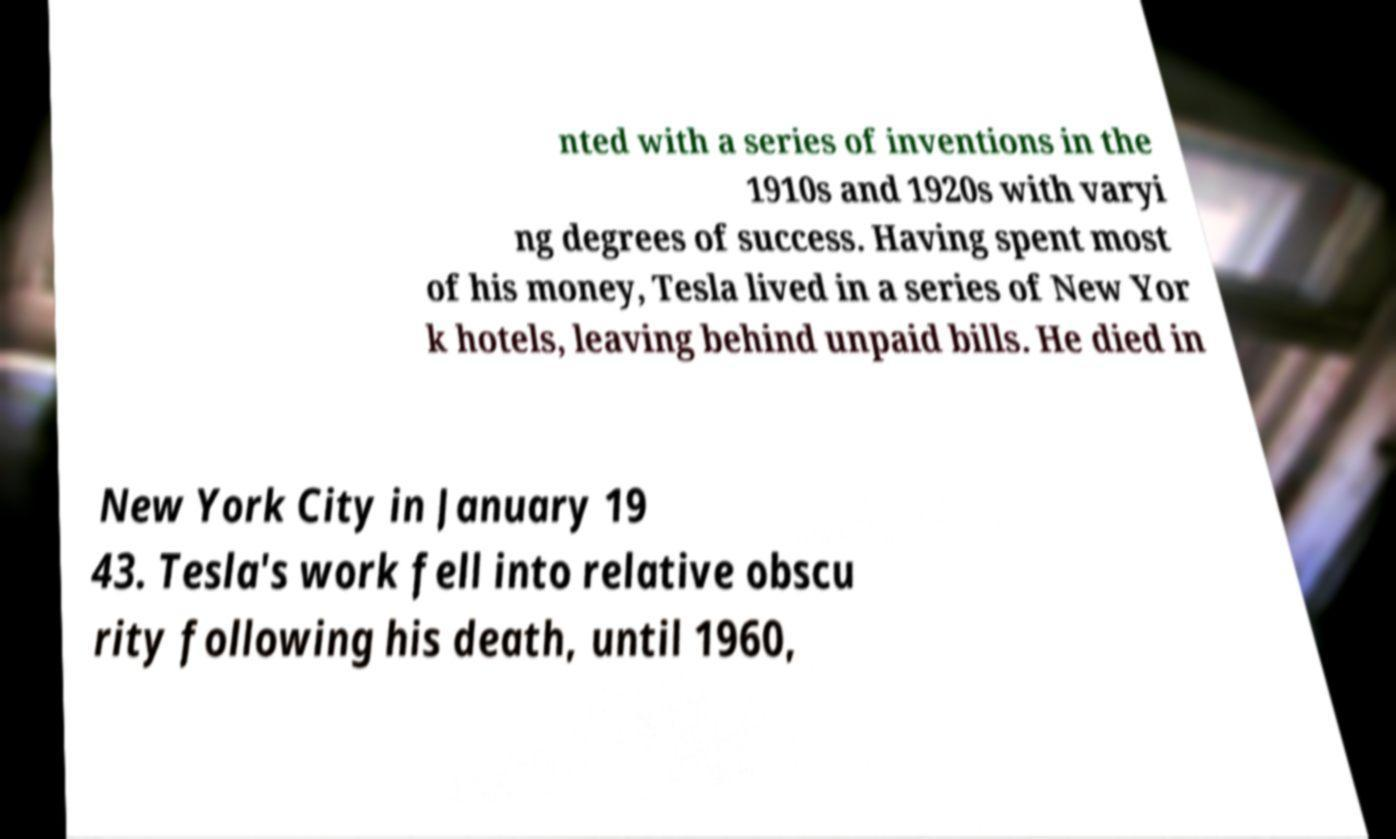Can you read and provide the text displayed in the image?This photo seems to have some interesting text. Can you extract and type it out for me? nted with a series of inventions in the 1910s and 1920s with varyi ng degrees of success. Having spent most of his money, Tesla lived in a series of New Yor k hotels, leaving behind unpaid bills. He died in New York City in January 19 43. Tesla's work fell into relative obscu rity following his death, until 1960, 